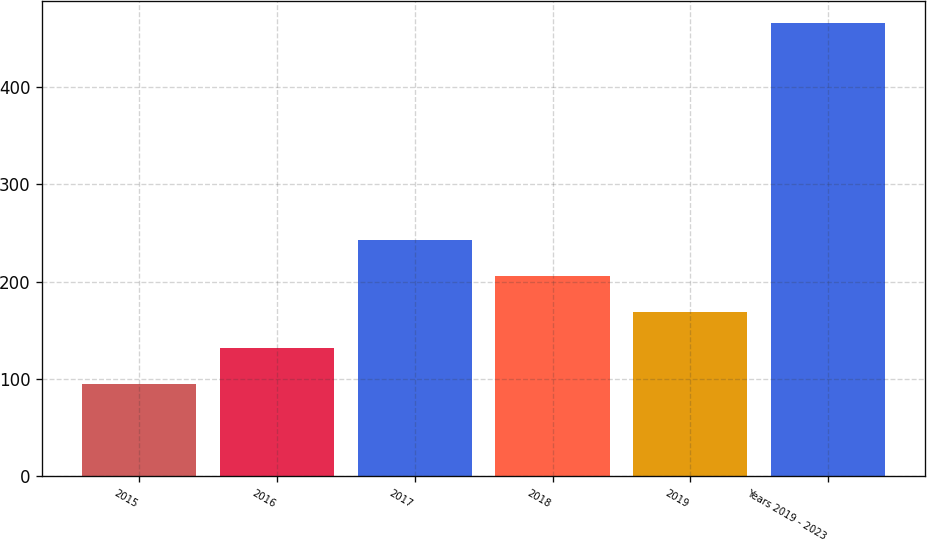Convert chart to OTSL. <chart><loc_0><loc_0><loc_500><loc_500><bar_chart><fcel>2015<fcel>2016<fcel>2017<fcel>2018<fcel>2019<fcel>Years 2019 - 2023<nl><fcel>95<fcel>132<fcel>243<fcel>206<fcel>169<fcel>465<nl></chart> 